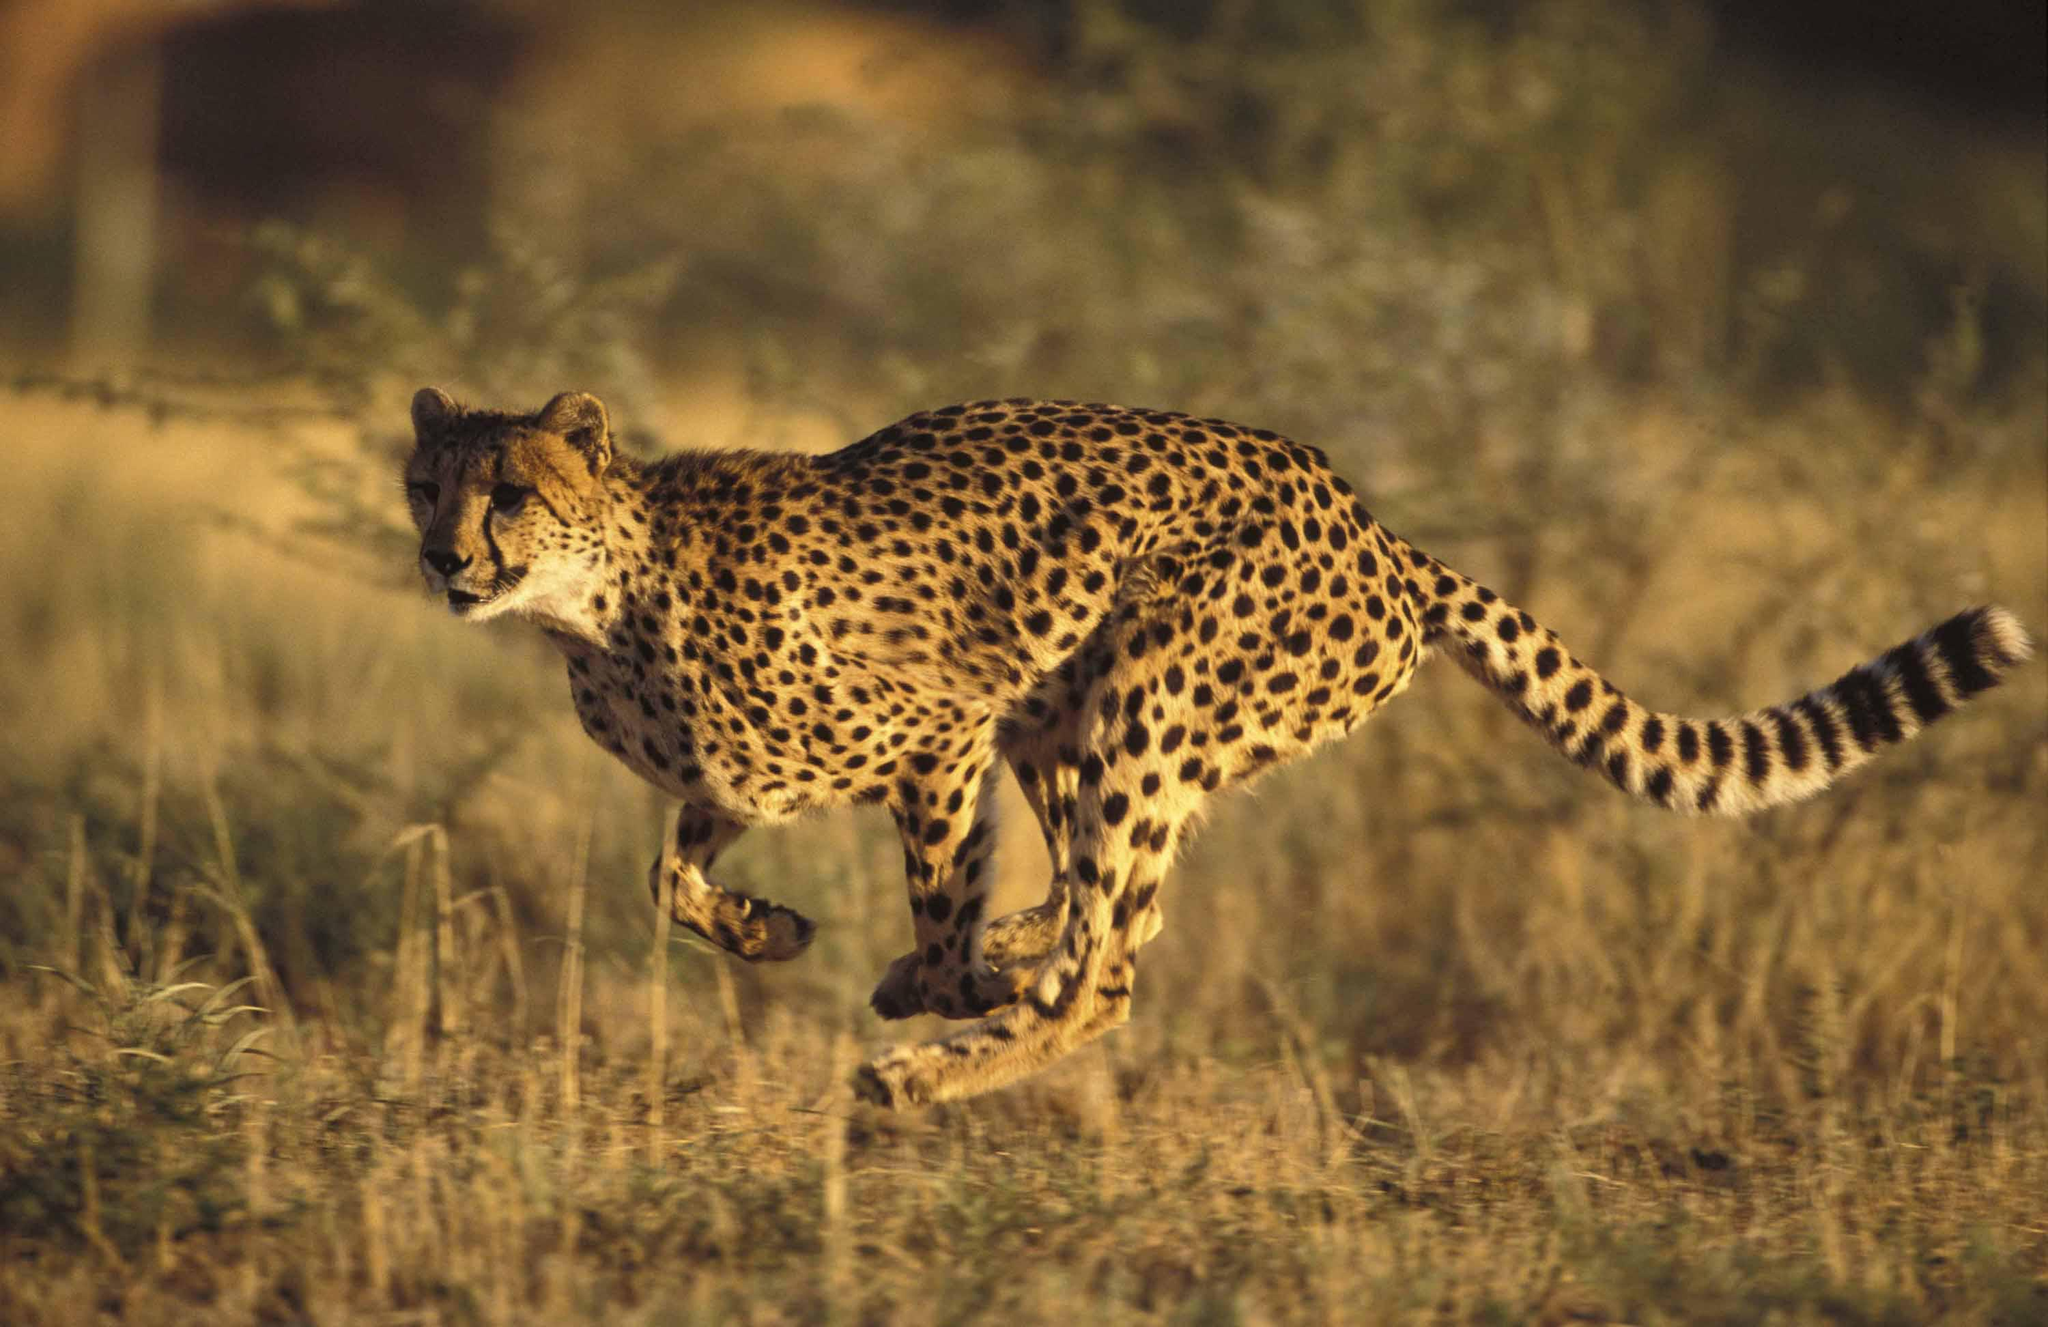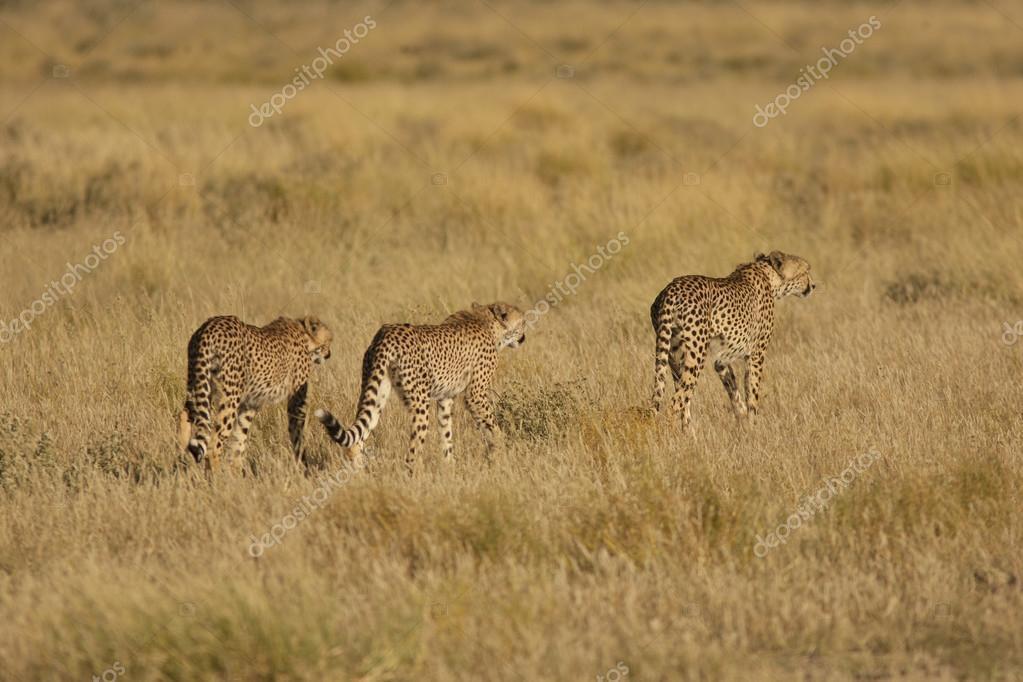The first image is the image on the left, the second image is the image on the right. Assess this claim about the two images: "There are exactly three animals in the image on the right.". Correct or not? Answer yes or no. Yes. The first image is the image on the left, the second image is the image on the right. Evaluate the accuracy of this statement regarding the images: "A wild cat with front paws extended is pouncing on visible prey in one image.". Is it true? Answer yes or no. No. 